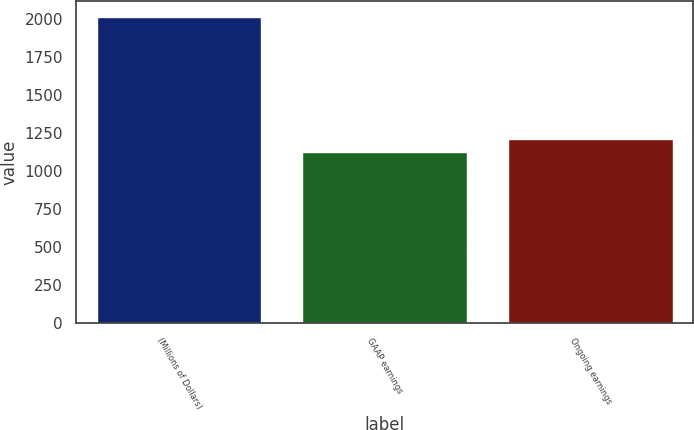Convert chart to OTSL. <chart><loc_0><loc_0><loc_500><loc_500><bar_chart><fcel>(Millions of Dollars)<fcel>GAAP earnings<fcel>Ongoing earnings<nl><fcel>2016<fcel>1123<fcel>1212.3<nl></chart> 